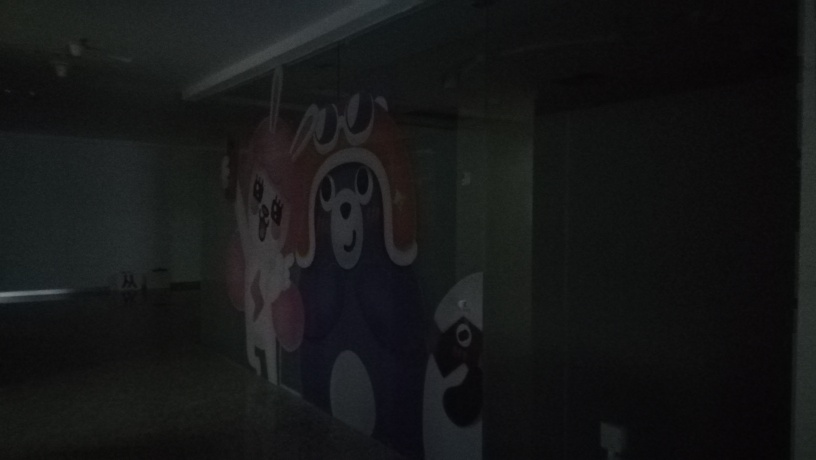How could this image be improved to better view the details? To improve the visibility of this image, more lighting would be needed. This could be natural light from opening nearby windows, if possible, or artificial light by turning on lights or using a camera flash. Additionally, adjusting the camera settings like ISO, exposure, and aperture can also result in a clearer picture. 